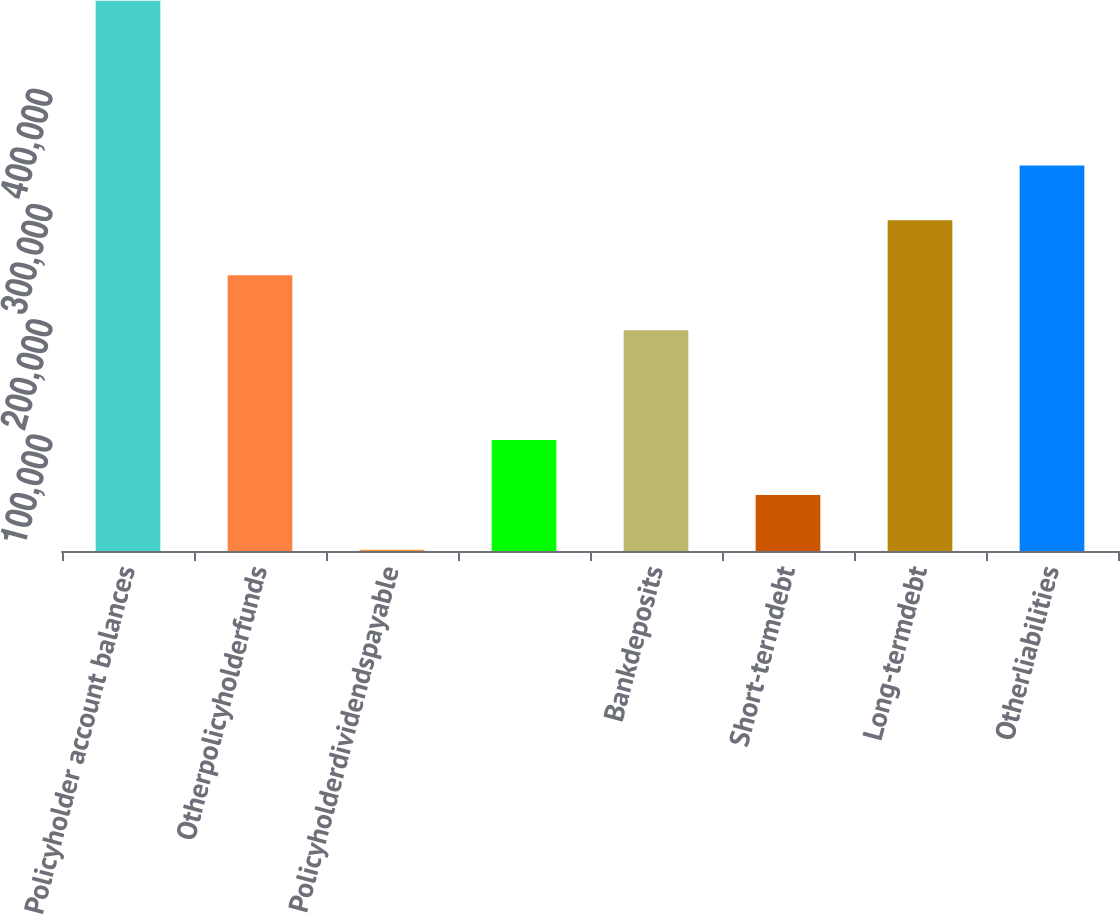Convert chart. <chart><loc_0><loc_0><loc_500><loc_500><bar_chart><fcel>Policyholder account balances<fcel>Otherpolicyholderfunds<fcel>Policyholderdividendspayable<fcel>Unnamed: 3<fcel>Bankdeposits<fcel>Short-termdebt<fcel>Long-termdebt<fcel>Otherliabilities<nl><fcel>477693<fcel>239358<fcel>1023<fcel>96357<fcel>191691<fcel>48690<fcel>287025<fcel>334692<nl></chart> 